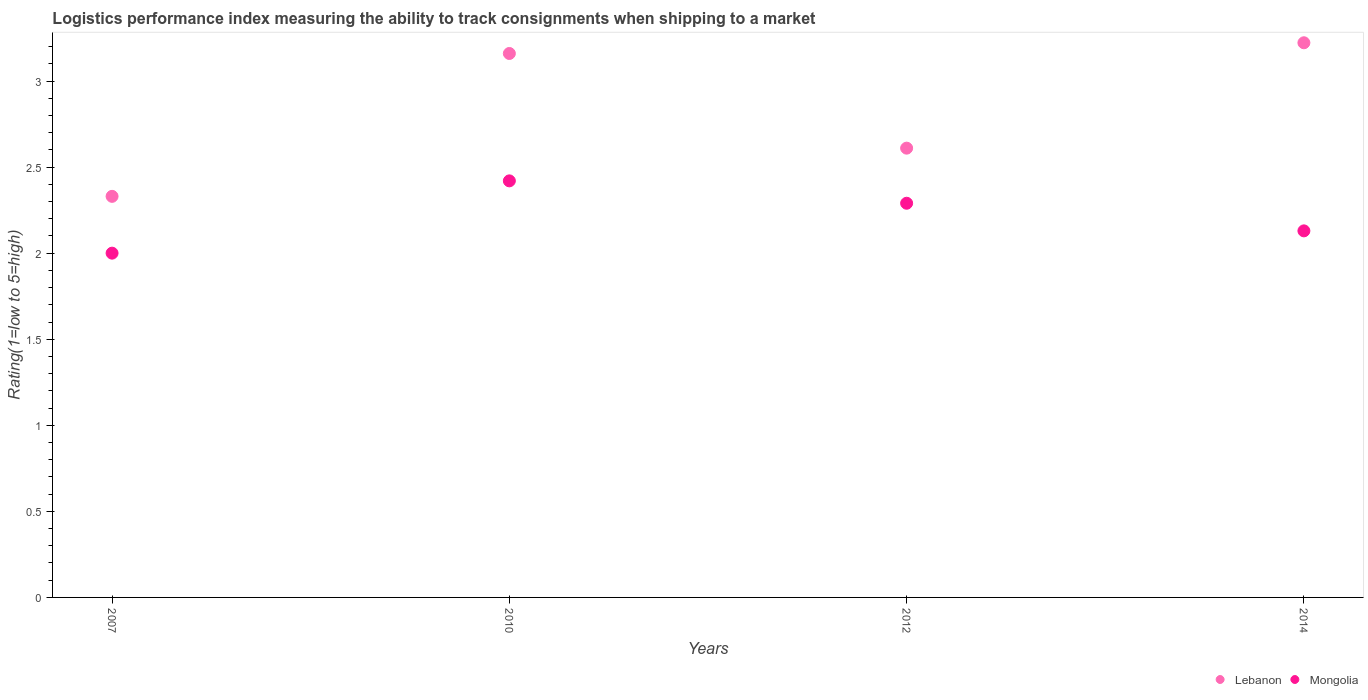Is the number of dotlines equal to the number of legend labels?
Make the answer very short. Yes. What is the Logistic performance index in Mongolia in 2010?
Make the answer very short. 2.42. Across all years, what is the maximum Logistic performance index in Lebanon?
Offer a terse response. 3.22. Across all years, what is the minimum Logistic performance index in Mongolia?
Your answer should be compact. 2. In which year was the Logistic performance index in Mongolia maximum?
Keep it short and to the point. 2010. In which year was the Logistic performance index in Mongolia minimum?
Keep it short and to the point. 2007. What is the total Logistic performance index in Lebanon in the graph?
Provide a succinct answer. 11.32. What is the difference between the Logistic performance index in Mongolia in 2007 and that in 2012?
Give a very brief answer. -0.29. What is the difference between the Logistic performance index in Mongolia in 2014 and the Logistic performance index in Lebanon in 2012?
Keep it short and to the point. -0.48. What is the average Logistic performance index in Lebanon per year?
Keep it short and to the point. 2.83. In the year 2007, what is the difference between the Logistic performance index in Mongolia and Logistic performance index in Lebanon?
Offer a terse response. -0.33. In how many years, is the Logistic performance index in Mongolia greater than 1.9?
Your answer should be very brief. 4. What is the ratio of the Logistic performance index in Lebanon in 2007 to that in 2014?
Provide a short and direct response. 0.72. What is the difference between the highest and the second highest Logistic performance index in Lebanon?
Keep it short and to the point. 0.06. What is the difference between the highest and the lowest Logistic performance index in Lebanon?
Ensure brevity in your answer.  0.89. In how many years, is the Logistic performance index in Mongolia greater than the average Logistic performance index in Mongolia taken over all years?
Make the answer very short. 2. Is the sum of the Logistic performance index in Mongolia in 2010 and 2014 greater than the maximum Logistic performance index in Lebanon across all years?
Your answer should be very brief. Yes. Does the Logistic performance index in Mongolia monotonically increase over the years?
Your response must be concise. No. Is the Logistic performance index in Lebanon strictly greater than the Logistic performance index in Mongolia over the years?
Your answer should be very brief. Yes. Is the Logistic performance index in Mongolia strictly less than the Logistic performance index in Lebanon over the years?
Provide a succinct answer. Yes. Where does the legend appear in the graph?
Offer a terse response. Bottom right. How many legend labels are there?
Provide a short and direct response. 2. How are the legend labels stacked?
Your response must be concise. Horizontal. What is the title of the graph?
Your response must be concise. Logistics performance index measuring the ability to track consignments when shipping to a market. Does "Burkina Faso" appear as one of the legend labels in the graph?
Your response must be concise. No. What is the label or title of the Y-axis?
Offer a very short reply. Rating(1=low to 5=high). What is the Rating(1=low to 5=high) in Lebanon in 2007?
Provide a succinct answer. 2.33. What is the Rating(1=low to 5=high) in Mongolia in 2007?
Ensure brevity in your answer.  2. What is the Rating(1=low to 5=high) of Lebanon in 2010?
Provide a short and direct response. 3.16. What is the Rating(1=low to 5=high) in Mongolia in 2010?
Your response must be concise. 2.42. What is the Rating(1=low to 5=high) of Lebanon in 2012?
Offer a terse response. 2.61. What is the Rating(1=low to 5=high) of Mongolia in 2012?
Provide a short and direct response. 2.29. What is the Rating(1=low to 5=high) of Lebanon in 2014?
Your answer should be compact. 3.22. What is the Rating(1=low to 5=high) of Mongolia in 2014?
Make the answer very short. 2.13. Across all years, what is the maximum Rating(1=low to 5=high) in Lebanon?
Provide a short and direct response. 3.22. Across all years, what is the maximum Rating(1=low to 5=high) in Mongolia?
Provide a short and direct response. 2.42. Across all years, what is the minimum Rating(1=low to 5=high) in Lebanon?
Ensure brevity in your answer.  2.33. What is the total Rating(1=low to 5=high) in Lebanon in the graph?
Your answer should be very brief. 11.32. What is the total Rating(1=low to 5=high) in Mongolia in the graph?
Your answer should be very brief. 8.84. What is the difference between the Rating(1=low to 5=high) in Lebanon in 2007 and that in 2010?
Offer a terse response. -0.83. What is the difference between the Rating(1=low to 5=high) in Mongolia in 2007 and that in 2010?
Give a very brief answer. -0.42. What is the difference between the Rating(1=low to 5=high) in Lebanon in 2007 and that in 2012?
Provide a succinct answer. -0.28. What is the difference between the Rating(1=low to 5=high) of Mongolia in 2007 and that in 2012?
Make the answer very short. -0.29. What is the difference between the Rating(1=low to 5=high) of Lebanon in 2007 and that in 2014?
Offer a very short reply. -0.89. What is the difference between the Rating(1=low to 5=high) in Mongolia in 2007 and that in 2014?
Offer a very short reply. -0.13. What is the difference between the Rating(1=low to 5=high) of Lebanon in 2010 and that in 2012?
Provide a succinct answer. 0.55. What is the difference between the Rating(1=low to 5=high) of Mongolia in 2010 and that in 2012?
Offer a terse response. 0.13. What is the difference between the Rating(1=low to 5=high) of Lebanon in 2010 and that in 2014?
Your answer should be compact. -0.06. What is the difference between the Rating(1=low to 5=high) in Mongolia in 2010 and that in 2014?
Provide a short and direct response. 0.29. What is the difference between the Rating(1=low to 5=high) in Lebanon in 2012 and that in 2014?
Make the answer very short. -0.61. What is the difference between the Rating(1=low to 5=high) of Mongolia in 2012 and that in 2014?
Provide a succinct answer. 0.16. What is the difference between the Rating(1=low to 5=high) of Lebanon in 2007 and the Rating(1=low to 5=high) of Mongolia in 2010?
Keep it short and to the point. -0.09. What is the difference between the Rating(1=low to 5=high) in Lebanon in 2007 and the Rating(1=low to 5=high) in Mongolia in 2012?
Offer a terse response. 0.04. What is the difference between the Rating(1=low to 5=high) of Lebanon in 2007 and the Rating(1=low to 5=high) of Mongolia in 2014?
Offer a terse response. 0.2. What is the difference between the Rating(1=low to 5=high) of Lebanon in 2010 and the Rating(1=low to 5=high) of Mongolia in 2012?
Offer a terse response. 0.87. What is the difference between the Rating(1=low to 5=high) in Lebanon in 2010 and the Rating(1=low to 5=high) in Mongolia in 2014?
Offer a terse response. 1.03. What is the difference between the Rating(1=low to 5=high) in Lebanon in 2012 and the Rating(1=low to 5=high) in Mongolia in 2014?
Give a very brief answer. 0.48. What is the average Rating(1=low to 5=high) of Lebanon per year?
Provide a short and direct response. 2.83. What is the average Rating(1=low to 5=high) in Mongolia per year?
Make the answer very short. 2.21. In the year 2007, what is the difference between the Rating(1=low to 5=high) in Lebanon and Rating(1=low to 5=high) in Mongolia?
Offer a very short reply. 0.33. In the year 2010, what is the difference between the Rating(1=low to 5=high) of Lebanon and Rating(1=low to 5=high) of Mongolia?
Ensure brevity in your answer.  0.74. In the year 2012, what is the difference between the Rating(1=low to 5=high) of Lebanon and Rating(1=low to 5=high) of Mongolia?
Your answer should be compact. 0.32. In the year 2014, what is the difference between the Rating(1=low to 5=high) of Lebanon and Rating(1=low to 5=high) of Mongolia?
Provide a succinct answer. 1.09. What is the ratio of the Rating(1=low to 5=high) in Lebanon in 2007 to that in 2010?
Offer a terse response. 0.74. What is the ratio of the Rating(1=low to 5=high) in Mongolia in 2007 to that in 2010?
Keep it short and to the point. 0.83. What is the ratio of the Rating(1=low to 5=high) in Lebanon in 2007 to that in 2012?
Offer a very short reply. 0.89. What is the ratio of the Rating(1=low to 5=high) of Mongolia in 2007 to that in 2012?
Make the answer very short. 0.87. What is the ratio of the Rating(1=low to 5=high) of Lebanon in 2007 to that in 2014?
Provide a succinct answer. 0.72. What is the ratio of the Rating(1=low to 5=high) of Mongolia in 2007 to that in 2014?
Ensure brevity in your answer.  0.94. What is the ratio of the Rating(1=low to 5=high) of Lebanon in 2010 to that in 2012?
Provide a succinct answer. 1.21. What is the ratio of the Rating(1=low to 5=high) in Mongolia in 2010 to that in 2012?
Your response must be concise. 1.06. What is the ratio of the Rating(1=low to 5=high) in Lebanon in 2010 to that in 2014?
Ensure brevity in your answer.  0.98. What is the ratio of the Rating(1=low to 5=high) in Mongolia in 2010 to that in 2014?
Provide a succinct answer. 1.14. What is the ratio of the Rating(1=low to 5=high) in Lebanon in 2012 to that in 2014?
Offer a terse response. 0.81. What is the ratio of the Rating(1=low to 5=high) of Mongolia in 2012 to that in 2014?
Make the answer very short. 1.08. What is the difference between the highest and the second highest Rating(1=low to 5=high) in Lebanon?
Ensure brevity in your answer.  0.06. What is the difference between the highest and the second highest Rating(1=low to 5=high) of Mongolia?
Offer a very short reply. 0.13. What is the difference between the highest and the lowest Rating(1=low to 5=high) in Lebanon?
Your response must be concise. 0.89. What is the difference between the highest and the lowest Rating(1=low to 5=high) of Mongolia?
Your answer should be very brief. 0.42. 